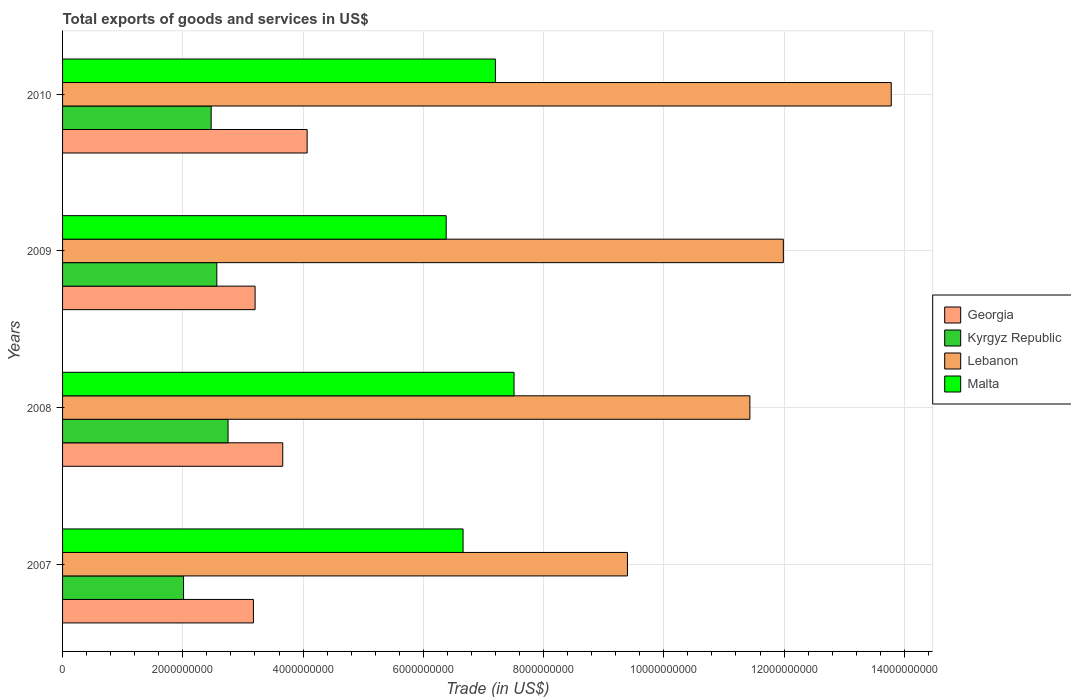How many groups of bars are there?
Offer a terse response. 4. Are the number of bars per tick equal to the number of legend labels?
Ensure brevity in your answer.  Yes. How many bars are there on the 2nd tick from the top?
Your response must be concise. 4. What is the label of the 4th group of bars from the top?
Provide a short and direct response. 2007. What is the total exports of goods and services in Georgia in 2009?
Your response must be concise. 3.20e+09. Across all years, what is the maximum total exports of goods and services in Georgia?
Provide a short and direct response. 4.07e+09. Across all years, what is the minimum total exports of goods and services in Lebanon?
Your response must be concise. 9.40e+09. What is the total total exports of goods and services in Georgia in the graph?
Your answer should be very brief. 1.41e+1. What is the difference between the total exports of goods and services in Georgia in 2007 and that in 2008?
Ensure brevity in your answer.  -4.87e+08. What is the difference between the total exports of goods and services in Kyrgyz Republic in 2010 and the total exports of goods and services in Georgia in 2008?
Your answer should be very brief. -1.19e+09. What is the average total exports of goods and services in Lebanon per year?
Your answer should be very brief. 1.16e+1. In the year 2010, what is the difference between the total exports of goods and services in Malta and total exports of goods and services in Kyrgyz Republic?
Your answer should be compact. 4.73e+09. What is the ratio of the total exports of goods and services in Georgia in 2009 to that in 2010?
Offer a very short reply. 0.79. Is the difference between the total exports of goods and services in Malta in 2009 and 2010 greater than the difference between the total exports of goods and services in Kyrgyz Republic in 2009 and 2010?
Provide a short and direct response. No. What is the difference between the highest and the second highest total exports of goods and services in Lebanon?
Ensure brevity in your answer.  1.79e+09. What is the difference between the highest and the lowest total exports of goods and services in Lebanon?
Your answer should be compact. 4.39e+09. In how many years, is the total exports of goods and services in Georgia greater than the average total exports of goods and services in Georgia taken over all years?
Offer a terse response. 2. What does the 1st bar from the top in 2008 represents?
Keep it short and to the point. Malta. What does the 2nd bar from the bottom in 2008 represents?
Give a very brief answer. Kyrgyz Republic. How many years are there in the graph?
Ensure brevity in your answer.  4. What is the difference between two consecutive major ticks on the X-axis?
Offer a very short reply. 2.00e+09. Are the values on the major ticks of X-axis written in scientific E-notation?
Ensure brevity in your answer.  No. Does the graph contain grids?
Keep it short and to the point. Yes. Where does the legend appear in the graph?
Your answer should be very brief. Center right. How many legend labels are there?
Provide a succinct answer. 4. What is the title of the graph?
Your answer should be compact. Total exports of goods and services in US$. What is the label or title of the X-axis?
Make the answer very short. Trade (in US$). What is the Trade (in US$) in Georgia in 2007?
Provide a short and direct response. 3.17e+09. What is the Trade (in US$) of Kyrgyz Republic in 2007?
Make the answer very short. 2.01e+09. What is the Trade (in US$) in Lebanon in 2007?
Your response must be concise. 9.40e+09. What is the Trade (in US$) in Malta in 2007?
Offer a terse response. 6.66e+09. What is the Trade (in US$) of Georgia in 2008?
Keep it short and to the point. 3.66e+09. What is the Trade (in US$) in Kyrgyz Republic in 2008?
Your answer should be very brief. 2.75e+09. What is the Trade (in US$) in Lebanon in 2008?
Provide a short and direct response. 1.14e+1. What is the Trade (in US$) in Malta in 2008?
Provide a succinct answer. 7.51e+09. What is the Trade (in US$) in Georgia in 2009?
Your response must be concise. 3.20e+09. What is the Trade (in US$) in Kyrgyz Republic in 2009?
Your answer should be compact. 2.57e+09. What is the Trade (in US$) in Lebanon in 2009?
Ensure brevity in your answer.  1.20e+1. What is the Trade (in US$) in Malta in 2009?
Make the answer very short. 6.38e+09. What is the Trade (in US$) in Georgia in 2010?
Offer a terse response. 4.07e+09. What is the Trade (in US$) in Kyrgyz Republic in 2010?
Provide a succinct answer. 2.47e+09. What is the Trade (in US$) in Lebanon in 2010?
Your answer should be very brief. 1.38e+1. What is the Trade (in US$) of Malta in 2010?
Ensure brevity in your answer.  7.20e+09. Across all years, what is the maximum Trade (in US$) in Georgia?
Your response must be concise. 4.07e+09. Across all years, what is the maximum Trade (in US$) of Kyrgyz Republic?
Make the answer very short. 2.75e+09. Across all years, what is the maximum Trade (in US$) of Lebanon?
Give a very brief answer. 1.38e+1. Across all years, what is the maximum Trade (in US$) in Malta?
Offer a terse response. 7.51e+09. Across all years, what is the minimum Trade (in US$) in Georgia?
Your response must be concise. 3.17e+09. Across all years, what is the minimum Trade (in US$) in Kyrgyz Republic?
Offer a terse response. 2.01e+09. Across all years, what is the minimum Trade (in US$) of Lebanon?
Offer a terse response. 9.40e+09. Across all years, what is the minimum Trade (in US$) in Malta?
Make the answer very short. 6.38e+09. What is the total Trade (in US$) in Georgia in the graph?
Provide a succinct answer. 1.41e+1. What is the total Trade (in US$) of Kyrgyz Republic in the graph?
Your answer should be compact. 9.80e+09. What is the total Trade (in US$) of Lebanon in the graph?
Your answer should be compact. 4.66e+1. What is the total Trade (in US$) of Malta in the graph?
Provide a short and direct response. 2.77e+1. What is the difference between the Trade (in US$) of Georgia in 2007 and that in 2008?
Your response must be concise. -4.87e+08. What is the difference between the Trade (in US$) of Kyrgyz Republic in 2007 and that in 2008?
Ensure brevity in your answer.  -7.40e+08. What is the difference between the Trade (in US$) of Lebanon in 2007 and that in 2008?
Provide a short and direct response. -2.04e+09. What is the difference between the Trade (in US$) of Malta in 2007 and that in 2008?
Offer a very short reply. -8.48e+08. What is the difference between the Trade (in US$) of Georgia in 2007 and that in 2009?
Provide a short and direct response. -2.75e+07. What is the difference between the Trade (in US$) of Kyrgyz Republic in 2007 and that in 2009?
Provide a succinct answer. -5.53e+08. What is the difference between the Trade (in US$) in Lebanon in 2007 and that in 2009?
Make the answer very short. -2.59e+09. What is the difference between the Trade (in US$) in Malta in 2007 and that in 2009?
Your answer should be compact. 2.81e+08. What is the difference between the Trade (in US$) of Georgia in 2007 and that in 2010?
Make the answer very short. -8.93e+08. What is the difference between the Trade (in US$) of Kyrgyz Republic in 2007 and that in 2010?
Your answer should be very brief. -4.60e+08. What is the difference between the Trade (in US$) in Lebanon in 2007 and that in 2010?
Keep it short and to the point. -4.39e+09. What is the difference between the Trade (in US$) in Malta in 2007 and that in 2010?
Give a very brief answer. -5.37e+08. What is the difference between the Trade (in US$) of Georgia in 2008 and that in 2009?
Ensure brevity in your answer.  4.60e+08. What is the difference between the Trade (in US$) of Kyrgyz Republic in 2008 and that in 2009?
Offer a terse response. 1.87e+08. What is the difference between the Trade (in US$) in Lebanon in 2008 and that in 2009?
Ensure brevity in your answer.  -5.57e+08. What is the difference between the Trade (in US$) of Malta in 2008 and that in 2009?
Your answer should be compact. 1.13e+09. What is the difference between the Trade (in US$) of Georgia in 2008 and that in 2010?
Your answer should be very brief. -4.06e+08. What is the difference between the Trade (in US$) of Kyrgyz Republic in 2008 and that in 2010?
Provide a succinct answer. 2.81e+08. What is the difference between the Trade (in US$) of Lebanon in 2008 and that in 2010?
Make the answer very short. -2.35e+09. What is the difference between the Trade (in US$) in Malta in 2008 and that in 2010?
Ensure brevity in your answer.  3.10e+08. What is the difference between the Trade (in US$) of Georgia in 2009 and that in 2010?
Your answer should be compact. -8.66e+08. What is the difference between the Trade (in US$) of Kyrgyz Republic in 2009 and that in 2010?
Your response must be concise. 9.37e+07. What is the difference between the Trade (in US$) in Lebanon in 2009 and that in 2010?
Offer a very short reply. -1.79e+09. What is the difference between the Trade (in US$) in Malta in 2009 and that in 2010?
Provide a succinct answer. -8.18e+08. What is the difference between the Trade (in US$) of Georgia in 2007 and the Trade (in US$) of Kyrgyz Republic in 2008?
Offer a terse response. 4.22e+08. What is the difference between the Trade (in US$) in Georgia in 2007 and the Trade (in US$) in Lebanon in 2008?
Make the answer very short. -8.26e+09. What is the difference between the Trade (in US$) of Georgia in 2007 and the Trade (in US$) of Malta in 2008?
Your response must be concise. -4.33e+09. What is the difference between the Trade (in US$) in Kyrgyz Republic in 2007 and the Trade (in US$) in Lebanon in 2008?
Offer a very short reply. -9.42e+09. What is the difference between the Trade (in US$) in Kyrgyz Republic in 2007 and the Trade (in US$) in Malta in 2008?
Your answer should be compact. -5.50e+09. What is the difference between the Trade (in US$) of Lebanon in 2007 and the Trade (in US$) of Malta in 2008?
Keep it short and to the point. 1.89e+09. What is the difference between the Trade (in US$) of Georgia in 2007 and the Trade (in US$) of Kyrgyz Republic in 2009?
Offer a terse response. 6.09e+08. What is the difference between the Trade (in US$) in Georgia in 2007 and the Trade (in US$) in Lebanon in 2009?
Give a very brief answer. -8.81e+09. What is the difference between the Trade (in US$) of Georgia in 2007 and the Trade (in US$) of Malta in 2009?
Provide a short and direct response. -3.21e+09. What is the difference between the Trade (in US$) in Kyrgyz Republic in 2007 and the Trade (in US$) in Lebanon in 2009?
Provide a short and direct response. -9.98e+09. What is the difference between the Trade (in US$) of Kyrgyz Republic in 2007 and the Trade (in US$) of Malta in 2009?
Provide a succinct answer. -4.37e+09. What is the difference between the Trade (in US$) of Lebanon in 2007 and the Trade (in US$) of Malta in 2009?
Provide a short and direct response. 3.01e+09. What is the difference between the Trade (in US$) of Georgia in 2007 and the Trade (in US$) of Kyrgyz Republic in 2010?
Offer a terse response. 7.03e+08. What is the difference between the Trade (in US$) of Georgia in 2007 and the Trade (in US$) of Lebanon in 2010?
Your response must be concise. -1.06e+1. What is the difference between the Trade (in US$) in Georgia in 2007 and the Trade (in US$) in Malta in 2010?
Your response must be concise. -4.02e+09. What is the difference between the Trade (in US$) of Kyrgyz Republic in 2007 and the Trade (in US$) of Lebanon in 2010?
Give a very brief answer. -1.18e+1. What is the difference between the Trade (in US$) of Kyrgyz Republic in 2007 and the Trade (in US$) of Malta in 2010?
Your answer should be compact. -5.19e+09. What is the difference between the Trade (in US$) of Lebanon in 2007 and the Trade (in US$) of Malta in 2010?
Your answer should be compact. 2.20e+09. What is the difference between the Trade (in US$) in Georgia in 2008 and the Trade (in US$) in Kyrgyz Republic in 2009?
Your answer should be very brief. 1.10e+09. What is the difference between the Trade (in US$) of Georgia in 2008 and the Trade (in US$) of Lebanon in 2009?
Your response must be concise. -8.33e+09. What is the difference between the Trade (in US$) in Georgia in 2008 and the Trade (in US$) in Malta in 2009?
Your response must be concise. -2.72e+09. What is the difference between the Trade (in US$) in Kyrgyz Republic in 2008 and the Trade (in US$) in Lebanon in 2009?
Your response must be concise. -9.24e+09. What is the difference between the Trade (in US$) of Kyrgyz Republic in 2008 and the Trade (in US$) of Malta in 2009?
Make the answer very short. -3.63e+09. What is the difference between the Trade (in US$) in Lebanon in 2008 and the Trade (in US$) in Malta in 2009?
Provide a short and direct response. 5.05e+09. What is the difference between the Trade (in US$) of Georgia in 2008 and the Trade (in US$) of Kyrgyz Republic in 2010?
Offer a very short reply. 1.19e+09. What is the difference between the Trade (in US$) of Georgia in 2008 and the Trade (in US$) of Lebanon in 2010?
Your answer should be very brief. -1.01e+1. What is the difference between the Trade (in US$) in Georgia in 2008 and the Trade (in US$) in Malta in 2010?
Ensure brevity in your answer.  -3.54e+09. What is the difference between the Trade (in US$) in Kyrgyz Republic in 2008 and the Trade (in US$) in Lebanon in 2010?
Offer a very short reply. -1.10e+1. What is the difference between the Trade (in US$) of Kyrgyz Republic in 2008 and the Trade (in US$) of Malta in 2010?
Make the answer very short. -4.45e+09. What is the difference between the Trade (in US$) of Lebanon in 2008 and the Trade (in US$) of Malta in 2010?
Keep it short and to the point. 4.23e+09. What is the difference between the Trade (in US$) of Georgia in 2009 and the Trade (in US$) of Kyrgyz Republic in 2010?
Provide a short and direct response. 7.30e+08. What is the difference between the Trade (in US$) of Georgia in 2009 and the Trade (in US$) of Lebanon in 2010?
Your answer should be very brief. -1.06e+1. What is the difference between the Trade (in US$) in Georgia in 2009 and the Trade (in US$) in Malta in 2010?
Your response must be concise. -4.00e+09. What is the difference between the Trade (in US$) in Kyrgyz Republic in 2009 and the Trade (in US$) in Lebanon in 2010?
Your answer should be very brief. -1.12e+1. What is the difference between the Trade (in US$) of Kyrgyz Republic in 2009 and the Trade (in US$) of Malta in 2010?
Your answer should be compact. -4.63e+09. What is the difference between the Trade (in US$) in Lebanon in 2009 and the Trade (in US$) in Malta in 2010?
Your response must be concise. 4.79e+09. What is the average Trade (in US$) in Georgia per year?
Provide a short and direct response. 3.53e+09. What is the average Trade (in US$) in Kyrgyz Republic per year?
Keep it short and to the point. 2.45e+09. What is the average Trade (in US$) of Lebanon per year?
Offer a very short reply. 1.16e+1. What is the average Trade (in US$) of Malta per year?
Ensure brevity in your answer.  6.94e+09. In the year 2007, what is the difference between the Trade (in US$) of Georgia and Trade (in US$) of Kyrgyz Republic?
Keep it short and to the point. 1.16e+09. In the year 2007, what is the difference between the Trade (in US$) in Georgia and Trade (in US$) in Lebanon?
Provide a short and direct response. -6.22e+09. In the year 2007, what is the difference between the Trade (in US$) in Georgia and Trade (in US$) in Malta?
Provide a short and direct response. -3.49e+09. In the year 2007, what is the difference between the Trade (in US$) in Kyrgyz Republic and Trade (in US$) in Lebanon?
Your response must be concise. -7.38e+09. In the year 2007, what is the difference between the Trade (in US$) in Kyrgyz Republic and Trade (in US$) in Malta?
Offer a very short reply. -4.65e+09. In the year 2007, what is the difference between the Trade (in US$) of Lebanon and Trade (in US$) of Malta?
Provide a short and direct response. 2.73e+09. In the year 2008, what is the difference between the Trade (in US$) of Georgia and Trade (in US$) of Kyrgyz Republic?
Keep it short and to the point. 9.10e+08. In the year 2008, what is the difference between the Trade (in US$) of Georgia and Trade (in US$) of Lebanon?
Keep it short and to the point. -7.77e+09. In the year 2008, what is the difference between the Trade (in US$) of Georgia and Trade (in US$) of Malta?
Your answer should be very brief. -3.85e+09. In the year 2008, what is the difference between the Trade (in US$) in Kyrgyz Republic and Trade (in US$) in Lebanon?
Offer a very short reply. -8.68e+09. In the year 2008, what is the difference between the Trade (in US$) in Kyrgyz Republic and Trade (in US$) in Malta?
Make the answer very short. -4.76e+09. In the year 2008, what is the difference between the Trade (in US$) in Lebanon and Trade (in US$) in Malta?
Offer a terse response. 3.92e+09. In the year 2009, what is the difference between the Trade (in US$) in Georgia and Trade (in US$) in Kyrgyz Republic?
Your response must be concise. 6.37e+08. In the year 2009, what is the difference between the Trade (in US$) in Georgia and Trade (in US$) in Lebanon?
Your answer should be compact. -8.79e+09. In the year 2009, what is the difference between the Trade (in US$) in Georgia and Trade (in US$) in Malta?
Offer a terse response. -3.18e+09. In the year 2009, what is the difference between the Trade (in US$) of Kyrgyz Republic and Trade (in US$) of Lebanon?
Your response must be concise. -9.42e+09. In the year 2009, what is the difference between the Trade (in US$) of Kyrgyz Republic and Trade (in US$) of Malta?
Your answer should be compact. -3.82e+09. In the year 2009, what is the difference between the Trade (in US$) in Lebanon and Trade (in US$) in Malta?
Ensure brevity in your answer.  5.61e+09. In the year 2010, what is the difference between the Trade (in US$) in Georgia and Trade (in US$) in Kyrgyz Republic?
Your answer should be very brief. 1.60e+09. In the year 2010, what is the difference between the Trade (in US$) of Georgia and Trade (in US$) of Lebanon?
Your response must be concise. -9.71e+09. In the year 2010, what is the difference between the Trade (in US$) in Georgia and Trade (in US$) in Malta?
Make the answer very short. -3.13e+09. In the year 2010, what is the difference between the Trade (in US$) in Kyrgyz Republic and Trade (in US$) in Lebanon?
Ensure brevity in your answer.  -1.13e+1. In the year 2010, what is the difference between the Trade (in US$) in Kyrgyz Republic and Trade (in US$) in Malta?
Offer a terse response. -4.73e+09. In the year 2010, what is the difference between the Trade (in US$) in Lebanon and Trade (in US$) in Malta?
Keep it short and to the point. 6.58e+09. What is the ratio of the Trade (in US$) of Georgia in 2007 to that in 2008?
Your response must be concise. 0.87. What is the ratio of the Trade (in US$) in Kyrgyz Republic in 2007 to that in 2008?
Provide a short and direct response. 0.73. What is the ratio of the Trade (in US$) in Lebanon in 2007 to that in 2008?
Your answer should be very brief. 0.82. What is the ratio of the Trade (in US$) of Malta in 2007 to that in 2008?
Make the answer very short. 0.89. What is the ratio of the Trade (in US$) of Kyrgyz Republic in 2007 to that in 2009?
Provide a short and direct response. 0.78. What is the ratio of the Trade (in US$) in Lebanon in 2007 to that in 2009?
Your answer should be very brief. 0.78. What is the ratio of the Trade (in US$) of Malta in 2007 to that in 2009?
Your answer should be very brief. 1.04. What is the ratio of the Trade (in US$) in Georgia in 2007 to that in 2010?
Your answer should be compact. 0.78. What is the ratio of the Trade (in US$) of Kyrgyz Republic in 2007 to that in 2010?
Ensure brevity in your answer.  0.81. What is the ratio of the Trade (in US$) in Lebanon in 2007 to that in 2010?
Offer a very short reply. 0.68. What is the ratio of the Trade (in US$) in Malta in 2007 to that in 2010?
Make the answer very short. 0.93. What is the ratio of the Trade (in US$) in Georgia in 2008 to that in 2009?
Offer a very short reply. 1.14. What is the ratio of the Trade (in US$) in Kyrgyz Republic in 2008 to that in 2009?
Offer a very short reply. 1.07. What is the ratio of the Trade (in US$) of Lebanon in 2008 to that in 2009?
Make the answer very short. 0.95. What is the ratio of the Trade (in US$) in Malta in 2008 to that in 2009?
Provide a short and direct response. 1.18. What is the ratio of the Trade (in US$) of Georgia in 2008 to that in 2010?
Offer a terse response. 0.9. What is the ratio of the Trade (in US$) of Kyrgyz Republic in 2008 to that in 2010?
Keep it short and to the point. 1.11. What is the ratio of the Trade (in US$) of Lebanon in 2008 to that in 2010?
Ensure brevity in your answer.  0.83. What is the ratio of the Trade (in US$) in Malta in 2008 to that in 2010?
Give a very brief answer. 1.04. What is the ratio of the Trade (in US$) in Georgia in 2009 to that in 2010?
Your answer should be compact. 0.79. What is the ratio of the Trade (in US$) of Kyrgyz Republic in 2009 to that in 2010?
Give a very brief answer. 1.04. What is the ratio of the Trade (in US$) in Lebanon in 2009 to that in 2010?
Your response must be concise. 0.87. What is the ratio of the Trade (in US$) in Malta in 2009 to that in 2010?
Offer a very short reply. 0.89. What is the difference between the highest and the second highest Trade (in US$) in Georgia?
Ensure brevity in your answer.  4.06e+08. What is the difference between the highest and the second highest Trade (in US$) in Kyrgyz Republic?
Provide a short and direct response. 1.87e+08. What is the difference between the highest and the second highest Trade (in US$) in Lebanon?
Offer a very short reply. 1.79e+09. What is the difference between the highest and the second highest Trade (in US$) of Malta?
Keep it short and to the point. 3.10e+08. What is the difference between the highest and the lowest Trade (in US$) in Georgia?
Your answer should be very brief. 8.93e+08. What is the difference between the highest and the lowest Trade (in US$) in Kyrgyz Republic?
Your response must be concise. 7.40e+08. What is the difference between the highest and the lowest Trade (in US$) of Lebanon?
Your answer should be very brief. 4.39e+09. What is the difference between the highest and the lowest Trade (in US$) in Malta?
Keep it short and to the point. 1.13e+09. 